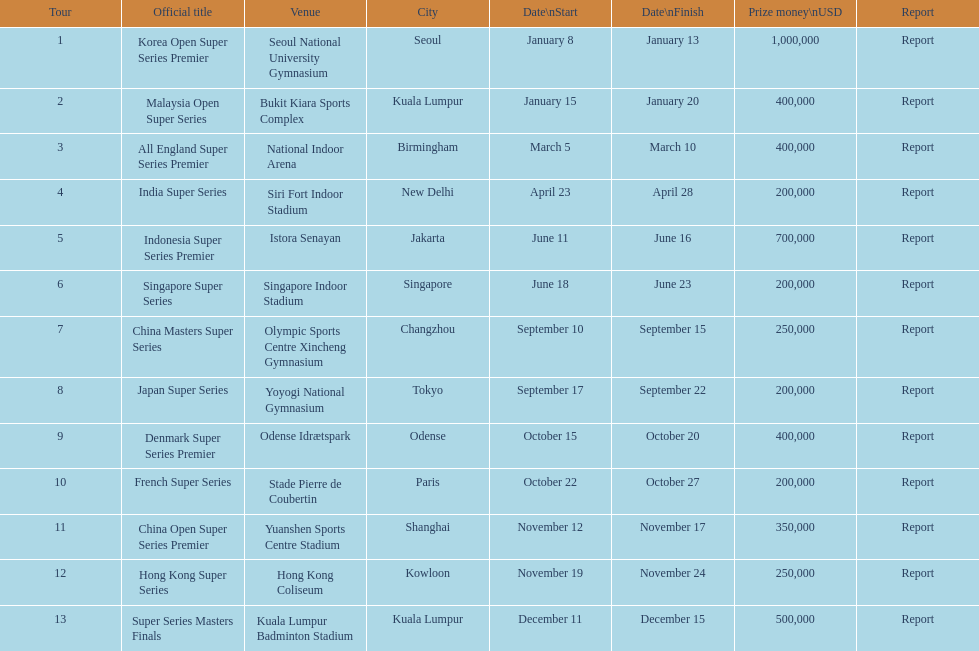How many series awarded at least $500,000 in prize money? 3. 